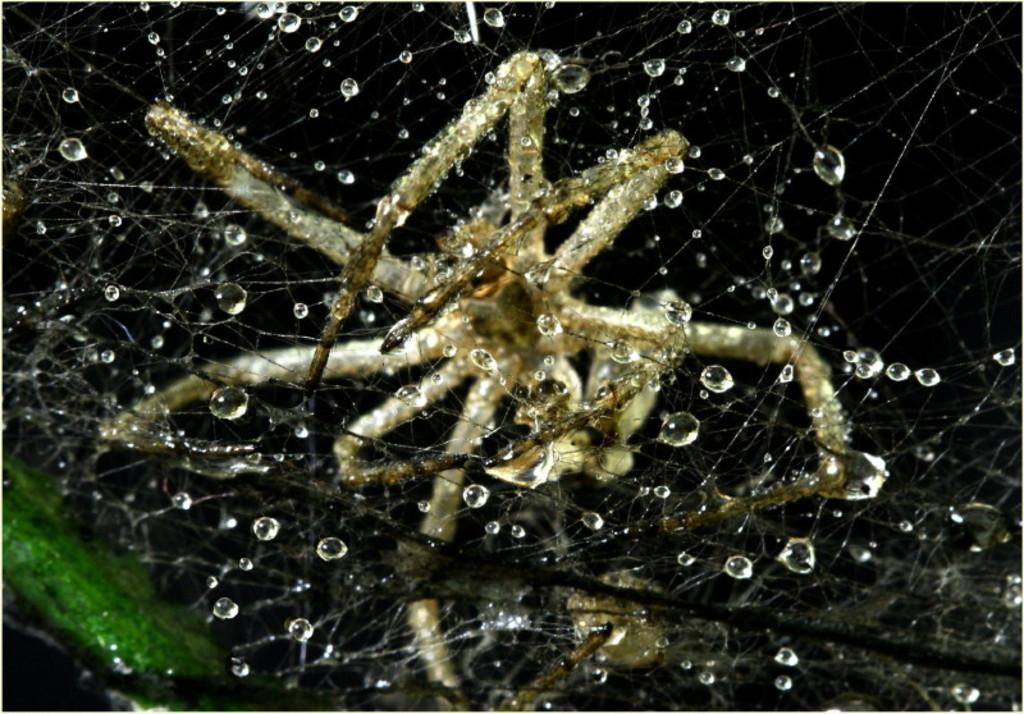What is the main subject of the image? The main subject of the image is a spider. Where is the spider located in the image? The spider is in its web. What type of hair can be seen on the spider in the image? There is no hair present on the spider in the image, as spiders do not have hair. Can you tell me how the spider is talking to the other spiders in the image? There are no other spiders present in the image, and spiders do not have the ability to talk. 